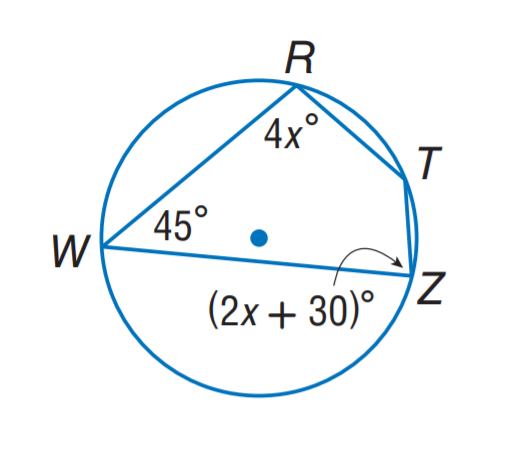Answer the mathemtical geometry problem and directly provide the correct option letter.
Question: Find m \angle Z.
Choices: A: 60 B: 80 C: 120 D: 135 B 